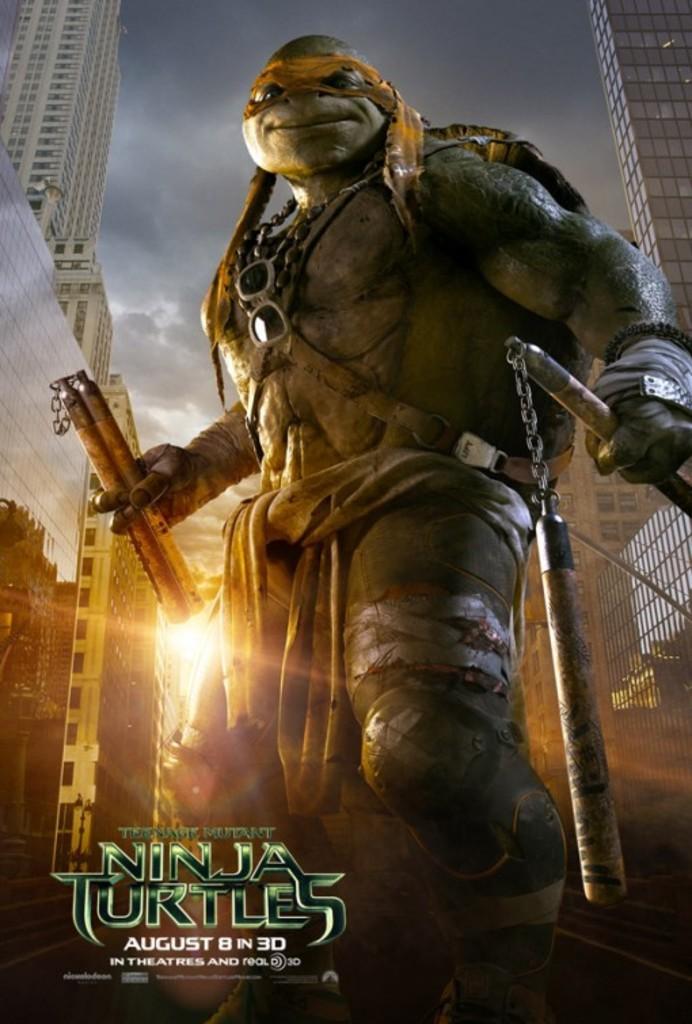Could you give a brief overview of what you see in this image? The picture is a poster. At the bottom there is text. In the center of the picture there is an animation looking like a turtle. The turtle is holding nunchucks. In the background there are buildings and sky. In the middle of the picture we can see sun. 